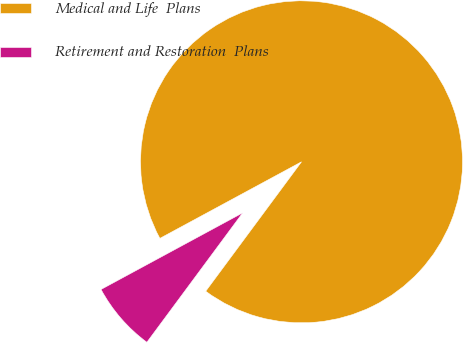Convert chart. <chart><loc_0><loc_0><loc_500><loc_500><pie_chart><fcel>Medical and Life  Plans<fcel>Retirement and Restoration  Plans<nl><fcel>93.03%<fcel>6.97%<nl></chart> 